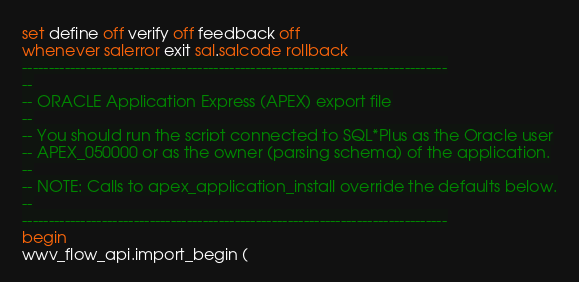Convert code to text. <code><loc_0><loc_0><loc_500><loc_500><_SQL_>set define off verify off feedback off
whenever sqlerror exit sql.sqlcode rollback
--------------------------------------------------------------------------------
--
-- ORACLE Application Express (APEX) export file
--
-- You should run the script connected to SQL*Plus as the Oracle user
-- APEX_050000 or as the owner (parsing schema) of the application.
--
-- NOTE: Calls to apex_application_install override the defaults below.
--
--------------------------------------------------------------------------------
begin
wwv_flow_api.import_begin (</code> 